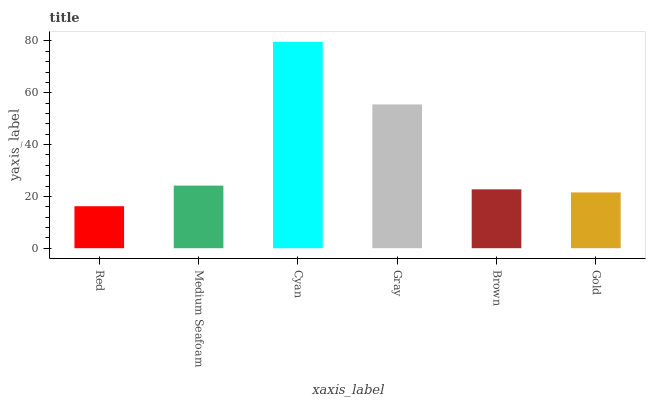Is Red the minimum?
Answer yes or no. Yes. Is Cyan the maximum?
Answer yes or no. Yes. Is Medium Seafoam the minimum?
Answer yes or no. No. Is Medium Seafoam the maximum?
Answer yes or no. No. Is Medium Seafoam greater than Red?
Answer yes or no. Yes. Is Red less than Medium Seafoam?
Answer yes or no. Yes. Is Red greater than Medium Seafoam?
Answer yes or no. No. Is Medium Seafoam less than Red?
Answer yes or no. No. Is Medium Seafoam the high median?
Answer yes or no. Yes. Is Brown the low median?
Answer yes or no. Yes. Is Red the high median?
Answer yes or no. No. Is Gray the low median?
Answer yes or no. No. 